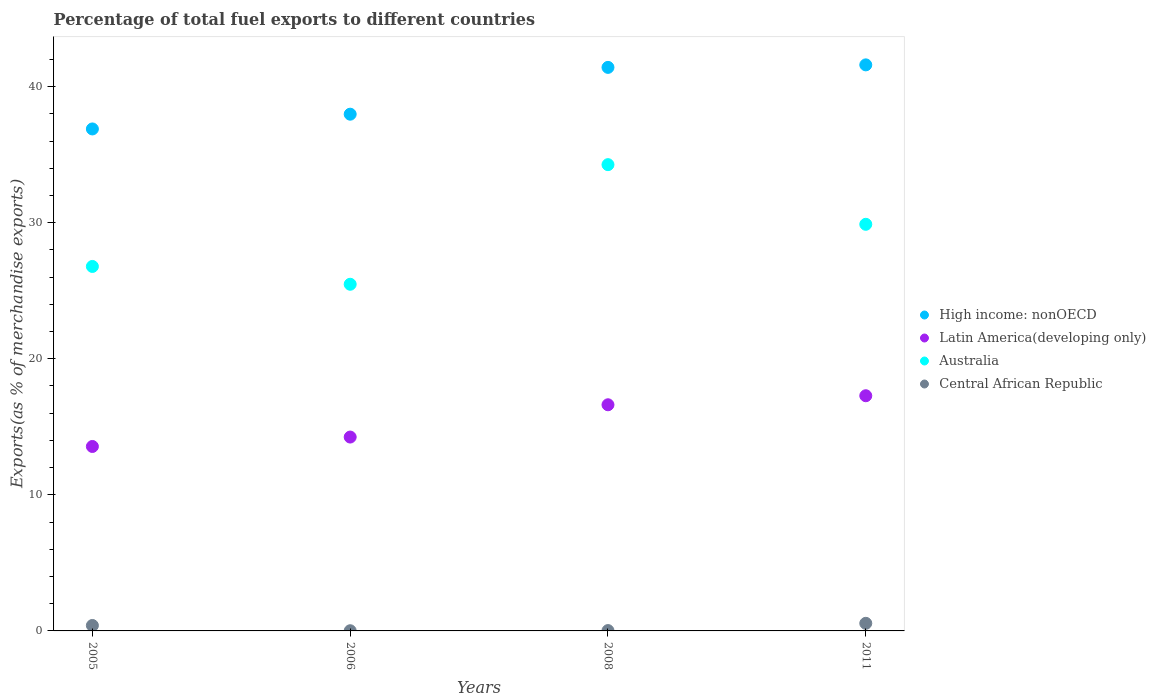How many different coloured dotlines are there?
Keep it short and to the point. 4. What is the percentage of exports to different countries in Central African Republic in 2006?
Your answer should be very brief. 0.01. Across all years, what is the maximum percentage of exports to different countries in High income: nonOECD?
Your answer should be very brief. 41.6. Across all years, what is the minimum percentage of exports to different countries in High income: nonOECD?
Ensure brevity in your answer.  36.89. What is the total percentage of exports to different countries in Latin America(developing only) in the graph?
Keep it short and to the point. 61.71. What is the difference between the percentage of exports to different countries in Central African Republic in 2005 and that in 2008?
Offer a terse response. 0.38. What is the difference between the percentage of exports to different countries in High income: nonOECD in 2006 and the percentage of exports to different countries in Australia in 2011?
Offer a very short reply. 8.09. What is the average percentage of exports to different countries in Central African Republic per year?
Offer a terse response. 0.25. In the year 2008, what is the difference between the percentage of exports to different countries in Latin America(developing only) and percentage of exports to different countries in High income: nonOECD?
Your answer should be compact. -24.8. In how many years, is the percentage of exports to different countries in Latin America(developing only) greater than 8 %?
Your answer should be compact. 4. What is the ratio of the percentage of exports to different countries in Central African Republic in 2006 to that in 2008?
Provide a succinct answer. 0.55. Is the difference between the percentage of exports to different countries in Latin America(developing only) in 2008 and 2011 greater than the difference between the percentage of exports to different countries in High income: nonOECD in 2008 and 2011?
Your answer should be very brief. No. What is the difference between the highest and the second highest percentage of exports to different countries in Central African Republic?
Offer a terse response. 0.16. What is the difference between the highest and the lowest percentage of exports to different countries in Latin America(developing only)?
Provide a succinct answer. 3.73. Is the sum of the percentage of exports to different countries in Australia in 2006 and 2008 greater than the maximum percentage of exports to different countries in Central African Republic across all years?
Provide a succinct answer. Yes. Is it the case that in every year, the sum of the percentage of exports to different countries in High income: nonOECD and percentage of exports to different countries in Central African Republic  is greater than the sum of percentage of exports to different countries in Latin America(developing only) and percentage of exports to different countries in Australia?
Make the answer very short. No. Does the percentage of exports to different countries in High income: nonOECD monotonically increase over the years?
Your response must be concise. Yes. Is the percentage of exports to different countries in Latin America(developing only) strictly greater than the percentage of exports to different countries in Australia over the years?
Your answer should be very brief. No. How many years are there in the graph?
Your answer should be compact. 4. What is the difference between two consecutive major ticks on the Y-axis?
Offer a very short reply. 10. Are the values on the major ticks of Y-axis written in scientific E-notation?
Keep it short and to the point. No. Does the graph contain any zero values?
Provide a succinct answer. No. Does the graph contain grids?
Your response must be concise. No. How many legend labels are there?
Give a very brief answer. 4. How are the legend labels stacked?
Provide a short and direct response. Vertical. What is the title of the graph?
Offer a terse response. Percentage of total fuel exports to different countries. Does "Faeroe Islands" appear as one of the legend labels in the graph?
Give a very brief answer. No. What is the label or title of the Y-axis?
Provide a short and direct response. Exports(as % of merchandise exports). What is the Exports(as % of merchandise exports) of High income: nonOECD in 2005?
Make the answer very short. 36.89. What is the Exports(as % of merchandise exports) of Latin America(developing only) in 2005?
Give a very brief answer. 13.56. What is the Exports(as % of merchandise exports) in Australia in 2005?
Give a very brief answer. 26.79. What is the Exports(as % of merchandise exports) of Central African Republic in 2005?
Provide a succinct answer. 0.4. What is the Exports(as % of merchandise exports) of High income: nonOECD in 2006?
Provide a short and direct response. 37.98. What is the Exports(as % of merchandise exports) in Latin America(developing only) in 2006?
Your answer should be compact. 14.25. What is the Exports(as % of merchandise exports) in Australia in 2006?
Your answer should be compact. 25.48. What is the Exports(as % of merchandise exports) in Central African Republic in 2006?
Offer a very short reply. 0.01. What is the Exports(as % of merchandise exports) in High income: nonOECD in 2008?
Provide a succinct answer. 41.42. What is the Exports(as % of merchandise exports) in Latin America(developing only) in 2008?
Your answer should be compact. 16.62. What is the Exports(as % of merchandise exports) in Australia in 2008?
Your answer should be very brief. 34.27. What is the Exports(as % of merchandise exports) in Central African Republic in 2008?
Your answer should be very brief. 0.02. What is the Exports(as % of merchandise exports) in High income: nonOECD in 2011?
Offer a very short reply. 41.6. What is the Exports(as % of merchandise exports) in Latin America(developing only) in 2011?
Give a very brief answer. 17.28. What is the Exports(as % of merchandise exports) of Australia in 2011?
Provide a short and direct response. 29.88. What is the Exports(as % of merchandise exports) of Central African Republic in 2011?
Offer a terse response. 0.56. Across all years, what is the maximum Exports(as % of merchandise exports) of High income: nonOECD?
Your response must be concise. 41.6. Across all years, what is the maximum Exports(as % of merchandise exports) in Latin America(developing only)?
Offer a terse response. 17.28. Across all years, what is the maximum Exports(as % of merchandise exports) of Australia?
Your answer should be very brief. 34.27. Across all years, what is the maximum Exports(as % of merchandise exports) in Central African Republic?
Provide a short and direct response. 0.56. Across all years, what is the minimum Exports(as % of merchandise exports) of High income: nonOECD?
Give a very brief answer. 36.89. Across all years, what is the minimum Exports(as % of merchandise exports) of Latin America(developing only)?
Provide a short and direct response. 13.56. Across all years, what is the minimum Exports(as % of merchandise exports) of Australia?
Ensure brevity in your answer.  25.48. Across all years, what is the minimum Exports(as % of merchandise exports) of Central African Republic?
Your response must be concise. 0.01. What is the total Exports(as % of merchandise exports) of High income: nonOECD in the graph?
Keep it short and to the point. 157.88. What is the total Exports(as % of merchandise exports) in Latin America(developing only) in the graph?
Keep it short and to the point. 61.71. What is the total Exports(as % of merchandise exports) in Australia in the graph?
Your response must be concise. 116.41. What is the total Exports(as % of merchandise exports) of Central African Republic in the graph?
Ensure brevity in your answer.  1. What is the difference between the Exports(as % of merchandise exports) in High income: nonOECD in 2005 and that in 2006?
Provide a succinct answer. -1.08. What is the difference between the Exports(as % of merchandise exports) of Latin America(developing only) in 2005 and that in 2006?
Keep it short and to the point. -0.69. What is the difference between the Exports(as % of merchandise exports) of Australia in 2005 and that in 2006?
Give a very brief answer. 1.31. What is the difference between the Exports(as % of merchandise exports) of Central African Republic in 2005 and that in 2006?
Offer a very short reply. 0.39. What is the difference between the Exports(as % of merchandise exports) of High income: nonOECD in 2005 and that in 2008?
Offer a terse response. -4.52. What is the difference between the Exports(as % of merchandise exports) in Latin America(developing only) in 2005 and that in 2008?
Provide a short and direct response. -3.07. What is the difference between the Exports(as % of merchandise exports) of Australia in 2005 and that in 2008?
Your answer should be very brief. -7.48. What is the difference between the Exports(as % of merchandise exports) of Central African Republic in 2005 and that in 2008?
Give a very brief answer. 0.38. What is the difference between the Exports(as % of merchandise exports) in High income: nonOECD in 2005 and that in 2011?
Offer a terse response. -4.71. What is the difference between the Exports(as % of merchandise exports) in Latin America(developing only) in 2005 and that in 2011?
Make the answer very short. -3.73. What is the difference between the Exports(as % of merchandise exports) of Australia in 2005 and that in 2011?
Offer a very short reply. -3.1. What is the difference between the Exports(as % of merchandise exports) of Central African Republic in 2005 and that in 2011?
Provide a short and direct response. -0.16. What is the difference between the Exports(as % of merchandise exports) in High income: nonOECD in 2006 and that in 2008?
Offer a terse response. -3.44. What is the difference between the Exports(as % of merchandise exports) in Latin America(developing only) in 2006 and that in 2008?
Provide a succinct answer. -2.37. What is the difference between the Exports(as % of merchandise exports) of Australia in 2006 and that in 2008?
Make the answer very short. -8.79. What is the difference between the Exports(as % of merchandise exports) of Central African Republic in 2006 and that in 2008?
Provide a short and direct response. -0.01. What is the difference between the Exports(as % of merchandise exports) of High income: nonOECD in 2006 and that in 2011?
Ensure brevity in your answer.  -3.62. What is the difference between the Exports(as % of merchandise exports) in Latin America(developing only) in 2006 and that in 2011?
Provide a short and direct response. -3.04. What is the difference between the Exports(as % of merchandise exports) of Australia in 2006 and that in 2011?
Keep it short and to the point. -4.41. What is the difference between the Exports(as % of merchandise exports) in Central African Republic in 2006 and that in 2011?
Keep it short and to the point. -0.54. What is the difference between the Exports(as % of merchandise exports) of High income: nonOECD in 2008 and that in 2011?
Ensure brevity in your answer.  -0.18. What is the difference between the Exports(as % of merchandise exports) of Latin America(developing only) in 2008 and that in 2011?
Ensure brevity in your answer.  -0.66. What is the difference between the Exports(as % of merchandise exports) in Australia in 2008 and that in 2011?
Make the answer very short. 4.38. What is the difference between the Exports(as % of merchandise exports) of Central African Republic in 2008 and that in 2011?
Your response must be concise. -0.53. What is the difference between the Exports(as % of merchandise exports) of High income: nonOECD in 2005 and the Exports(as % of merchandise exports) of Latin America(developing only) in 2006?
Offer a very short reply. 22.64. What is the difference between the Exports(as % of merchandise exports) of High income: nonOECD in 2005 and the Exports(as % of merchandise exports) of Australia in 2006?
Keep it short and to the point. 11.42. What is the difference between the Exports(as % of merchandise exports) in High income: nonOECD in 2005 and the Exports(as % of merchandise exports) in Central African Republic in 2006?
Ensure brevity in your answer.  36.88. What is the difference between the Exports(as % of merchandise exports) in Latin America(developing only) in 2005 and the Exports(as % of merchandise exports) in Australia in 2006?
Provide a short and direct response. -11.92. What is the difference between the Exports(as % of merchandise exports) in Latin America(developing only) in 2005 and the Exports(as % of merchandise exports) in Central African Republic in 2006?
Offer a terse response. 13.54. What is the difference between the Exports(as % of merchandise exports) of Australia in 2005 and the Exports(as % of merchandise exports) of Central African Republic in 2006?
Provide a succinct answer. 26.77. What is the difference between the Exports(as % of merchandise exports) of High income: nonOECD in 2005 and the Exports(as % of merchandise exports) of Latin America(developing only) in 2008?
Offer a very short reply. 20.27. What is the difference between the Exports(as % of merchandise exports) of High income: nonOECD in 2005 and the Exports(as % of merchandise exports) of Australia in 2008?
Make the answer very short. 2.62. What is the difference between the Exports(as % of merchandise exports) in High income: nonOECD in 2005 and the Exports(as % of merchandise exports) in Central African Republic in 2008?
Keep it short and to the point. 36.87. What is the difference between the Exports(as % of merchandise exports) in Latin America(developing only) in 2005 and the Exports(as % of merchandise exports) in Australia in 2008?
Your answer should be very brief. -20.71. What is the difference between the Exports(as % of merchandise exports) of Latin America(developing only) in 2005 and the Exports(as % of merchandise exports) of Central African Republic in 2008?
Your answer should be very brief. 13.53. What is the difference between the Exports(as % of merchandise exports) in Australia in 2005 and the Exports(as % of merchandise exports) in Central African Republic in 2008?
Provide a short and direct response. 26.76. What is the difference between the Exports(as % of merchandise exports) in High income: nonOECD in 2005 and the Exports(as % of merchandise exports) in Latin America(developing only) in 2011?
Offer a very short reply. 19.61. What is the difference between the Exports(as % of merchandise exports) in High income: nonOECD in 2005 and the Exports(as % of merchandise exports) in Australia in 2011?
Give a very brief answer. 7.01. What is the difference between the Exports(as % of merchandise exports) in High income: nonOECD in 2005 and the Exports(as % of merchandise exports) in Central African Republic in 2011?
Provide a succinct answer. 36.33. What is the difference between the Exports(as % of merchandise exports) of Latin America(developing only) in 2005 and the Exports(as % of merchandise exports) of Australia in 2011?
Make the answer very short. -16.33. What is the difference between the Exports(as % of merchandise exports) of Latin America(developing only) in 2005 and the Exports(as % of merchandise exports) of Central African Republic in 2011?
Your answer should be compact. 13. What is the difference between the Exports(as % of merchandise exports) of Australia in 2005 and the Exports(as % of merchandise exports) of Central African Republic in 2011?
Offer a terse response. 26.23. What is the difference between the Exports(as % of merchandise exports) of High income: nonOECD in 2006 and the Exports(as % of merchandise exports) of Latin America(developing only) in 2008?
Provide a short and direct response. 21.36. What is the difference between the Exports(as % of merchandise exports) in High income: nonOECD in 2006 and the Exports(as % of merchandise exports) in Australia in 2008?
Your answer should be compact. 3.71. What is the difference between the Exports(as % of merchandise exports) in High income: nonOECD in 2006 and the Exports(as % of merchandise exports) in Central African Republic in 2008?
Provide a short and direct response. 37.95. What is the difference between the Exports(as % of merchandise exports) in Latin America(developing only) in 2006 and the Exports(as % of merchandise exports) in Australia in 2008?
Keep it short and to the point. -20.02. What is the difference between the Exports(as % of merchandise exports) of Latin America(developing only) in 2006 and the Exports(as % of merchandise exports) of Central African Republic in 2008?
Your response must be concise. 14.22. What is the difference between the Exports(as % of merchandise exports) in Australia in 2006 and the Exports(as % of merchandise exports) in Central African Republic in 2008?
Give a very brief answer. 25.45. What is the difference between the Exports(as % of merchandise exports) of High income: nonOECD in 2006 and the Exports(as % of merchandise exports) of Latin America(developing only) in 2011?
Give a very brief answer. 20.69. What is the difference between the Exports(as % of merchandise exports) in High income: nonOECD in 2006 and the Exports(as % of merchandise exports) in Australia in 2011?
Provide a succinct answer. 8.09. What is the difference between the Exports(as % of merchandise exports) of High income: nonOECD in 2006 and the Exports(as % of merchandise exports) of Central African Republic in 2011?
Your response must be concise. 37.42. What is the difference between the Exports(as % of merchandise exports) in Latin America(developing only) in 2006 and the Exports(as % of merchandise exports) in Australia in 2011?
Provide a short and direct response. -15.64. What is the difference between the Exports(as % of merchandise exports) in Latin America(developing only) in 2006 and the Exports(as % of merchandise exports) in Central African Republic in 2011?
Your response must be concise. 13.69. What is the difference between the Exports(as % of merchandise exports) in Australia in 2006 and the Exports(as % of merchandise exports) in Central African Republic in 2011?
Make the answer very short. 24.92. What is the difference between the Exports(as % of merchandise exports) in High income: nonOECD in 2008 and the Exports(as % of merchandise exports) in Latin America(developing only) in 2011?
Provide a short and direct response. 24.13. What is the difference between the Exports(as % of merchandise exports) in High income: nonOECD in 2008 and the Exports(as % of merchandise exports) in Australia in 2011?
Give a very brief answer. 11.53. What is the difference between the Exports(as % of merchandise exports) of High income: nonOECD in 2008 and the Exports(as % of merchandise exports) of Central African Republic in 2011?
Your answer should be very brief. 40.86. What is the difference between the Exports(as % of merchandise exports) of Latin America(developing only) in 2008 and the Exports(as % of merchandise exports) of Australia in 2011?
Make the answer very short. -13.26. What is the difference between the Exports(as % of merchandise exports) of Latin America(developing only) in 2008 and the Exports(as % of merchandise exports) of Central African Republic in 2011?
Make the answer very short. 16.06. What is the difference between the Exports(as % of merchandise exports) of Australia in 2008 and the Exports(as % of merchandise exports) of Central African Republic in 2011?
Make the answer very short. 33.71. What is the average Exports(as % of merchandise exports) in High income: nonOECD per year?
Your response must be concise. 39.47. What is the average Exports(as % of merchandise exports) in Latin America(developing only) per year?
Give a very brief answer. 15.43. What is the average Exports(as % of merchandise exports) in Australia per year?
Give a very brief answer. 29.1. What is the average Exports(as % of merchandise exports) in Central African Republic per year?
Keep it short and to the point. 0.25. In the year 2005, what is the difference between the Exports(as % of merchandise exports) of High income: nonOECD and Exports(as % of merchandise exports) of Latin America(developing only)?
Make the answer very short. 23.34. In the year 2005, what is the difference between the Exports(as % of merchandise exports) of High income: nonOECD and Exports(as % of merchandise exports) of Australia?
Offer a very short reply. 10.11. In the year 2005, what is the difference between the Exports(as % of merchandise exports) in High income: nonOECD and Exports(as % of merchandise exports) in Central African Republic?
Provide a short and direct response. 36.49. In the year 2005, what is the difference between the Exports(as % of merchandise exports) of Latin America(developing only) and Exports(as % of merchandise exports) of Australia?
Offer a very short reply. -13.23. In the year 2005, what is the difference between the Exports(as % of merchandise exports) of Latin America(developing only) and Exports(as % of merchandise exports) of Central African Republic?
Make the answer very short. 13.16. In the year 2005, what is the difference between the Exports(as % of merchandise exports) in Australia and Exports(as % of merchandise exports) in Central African Republic?
Your answer should be compact. 26.39. In the year 2006, what is the difference between the Exports(as % of merchandise exports) in High income: nonOECD and Exports(as % of merchandise exports) in Latin America(developing only)?
Your answer should be compact. 23.73. In the year 2006, what is the difference between the Exports(as % of merchandise exports) in High income: nonOECD and Exports(as % of merchandise exports) in Australia?
Keep it short and to the point. 12.5. In the year 2006, what is the difference between the Exports(as % of merchandise exports) in High income: nonOECD and Exports(as % of merchandise exports) in Central African Republic?
Ensure brevity in your answer.  37.96. In the year 2006, what is the difference between the Exports(as % of merchandise exports) of Latin America(developing only) and Exports(as % of merchandise exports) of Australia?
Keep it short and to the point. -11.23. In the year 2006, what is the difference between the Exports(as % of merchandise exports) of Latin America(developing only) and Exports(as % of merchandise exports) of Central African Republic?
Ensure brevity in your answer.  14.23. In the year 2006, what is the difference between the Exports(as % of merchandise exports) of Australia and Exports(as % of merchandise exports) of Central African Republic?
Keep it short and to the point. 25.46. In the year 2008, what is the difference between the Exports(as % of merchandise exports) of High income: nonOECD and Exports(as % of merchandise exports) of Latin America(developing only)?
Keep it short and to the point. 24.8. In the year 2008, what is the difference between the Exports(as % of merchandise exports) of High income: nonOECD and Exports(as % of merchandise exports) of Australia?
Your response must be concise. 7.15. In the year 2008, what is the difference between the Exports(as % of merchandise exports) of High income: nonOECD and Exports(as % of merchandise exports) of Central African Republic?
Ensure brevity in your answer.  41.39. In the year 2008, what is the difference between the Exports(as % of merchandise exports) of Latin America(developing only) and Exports(as % of merchandise exports) of Australia?
Your answer should be compact. -17.65. In the year 2008, what is the difference between the Exports(as % of merchandise exports) in Latin America(developing only) and Exports(as % of merchandise exports) in Central African Republic?
Your answer should be compact. 16.6. In the year 2008, what is the difference between the Exports(as % of merchandise exports) in Australia and Exports(as % of merchandise exports) in Central African Republic?
Ensure brevity in your answer.  34.24. In the year 2011, what is the difference between the Exports(as % of merchandise exports) in High income: nonOECD and Exports(as % of merchandise exports) in Latin America(developing only)?
Give a very brief answer. 24.32. In the year 2011, what is the difference between the Exports(as % of merchandise exports) in High income: nonOECD and Exports(as % of merchandise exports) in Australia?
Your answer should be very brief. 11.72. In the year 2011, what is the difference between the Exports(as % of merchandise exports) of High income: nonOECD and Exports(as % of merchandise exports) of Central African Republic?
Provide a short and direct response. 41.04. In the year 2011, what is the difference between the Exports(as % of merchandise exports) of Latin America(developing only) and Exports(as % of merchandise exports) of Australia?
Your response must be concise. -12.6. In the year 2011, what is the difference between the Exports(as % of merchandise exports) of Latin America(developing only) and Exports(as % of merchandise exports) of Central African Republic?
Offer a terse response. 16.73. In the year 2011, what is the difference between the Exports(as % of merchandise exports) in Australia and Exports(as % of merchandise exports) in Central African Republic?
Provide a short and direct response. 29.32. What is the ratio of the Exports(as % of merchandise exports) in High income: nonOECD in 2005 to that in 2006?
Provide a succinct answer. 0.97. What is the ratio of the Exports(as % of merchandise exports) of Latin America(developing only) in 2005 to that in 2006?
Your answer should be compact. 0.95. What is the ratio of the Exports(as % of merchandise exports) of Australia in 2005 to that in 2006?
Ensure brevity in your answer.  1.05. What is the ratio of the Exports(as % of merchandise exports) in Central African Republic in 2005 to that in 2006?
Offer a terse response. 29.62. What is the ratio of the Exports(as % of merchandise exports) of High income: nonOECD in 2005 to that in 2008?
Ensure brevity in your answer.  0.89. What is the ratio of the Exports(as % of merchandise exports) in Latin America(developing only) in 2005 to that in 2008?
Your answer should be compact. 0.82. What is the ratio of the Exports(as % of merchandise exports) of Australia in 2005 to that in 2008?
Ensure brevity in your answer.  0.78. What is the ratio of the Exports(as % of merchandise exports) of Central African Republic in 2005 to that in 2008?
Provide a succinct answer. 16.35. What is the ratio of the Exports(as % of merchandise exports) of High income: nonOECD in 2005 to that in 2011?
Give a very brief answer. 0.89. What is the ratio of the Exports(as % of merchandise exports) of Latin America(developing only) in 2005 to that in 2011?
Keep it short and to the point. 0.78. What is the ratio of the Exports(as % of merchandise exports) of Australia in 2005 to that in 2011?
Offer a terse response. 0.9. What is the ratio of the Exports(as % of merchandise exports) in Central African Republic in 2005 to that in 2011?
Ensure brevity in your answer.  0.72. What is the ratio of the Exports(as % of merchandise exports) of High income: nonOECD in 2006 to that in 2008?
Your response must be concise. 0.92. What is the ratio of the Exports(as % of merchandise exports) of Latin America(developing only) in 2006 to that in 2008?
Make the answer very short. 0.86. What is the ratio of the Exports(as % of merchandise exports) in Australia in 2006 to that in 2008?
Offer a terse response. 0.74. What is the ratio of the Exports(as % of merchandise exports) of Central African Republic in 2006 to that in 2008?
Your answer should be compact. 0.55. What is the ratio of the Exports(as % of merchandise exports) in High income: nonOECD in 2006 to that in 2011?
Keep it short and to the point. 0.91. What is the ratio of the Exports(as % of merchandise exports) of Latin America(developing only) in 2006 to that in 2011?
Give a very brief answer. 0.82. What is the ratio of the Exports(as % of merchandise exports) in Australia in 2006 to that in 2011?
Your response must be concise. 0.85. What is the ratio of the Exports(as % of merchandise exports) of Central African Republic in 2006 to that in 2011?
Your answer should be compact. 0.02. What is the ratio of the Exports(as % of merchandise exports) of High income: nonOECD in 2008 to that in 2011?
Make the answer very short. 1. What is the ratio of the Exports(as % of merchandise exports) of Latin America(developing only) in 2008 to that in 2011?
Your response must be concise. 0.96. What is the ratio of the Exports(as % of merchandise exports) in Australia in 2008 to that in 2011?
Provide a short and direct response. 1.15. What is the ratio of the Exports(as % of merchandise exports) of Central African Republic in 2008 to that in 2011?
Your answer should be compact. 0.04. What is the difference between the highest and the second highest Exports(as % of merchandise exports) of High income: nonOECD?
Ensure brevity in your answer.  0.18. What is the difference between the highest and the second highest Exports(as % of merchandise exports) in Latin America(developing only)?
Give a very brief answer. 0.66. What is the difference between the highest and the second highest Exports(as % of merchandise exports) of Australia?
Keep it short and to the point. 4.38. What is the difference between the highest and the second highest Exports(as % of merchandise exports) of Central African Republic?
Keep it short and to the point. 0.16. What is the difference between the highest and the lowest Exports(as % of merchandise exports) in High income: nonOECD?
Your answer should be very brief. 4.71. What is the difference between the highest and the lowest Exports(as % of merchandise exports) of Latin America(developing only)?
Keep it short and to the point. 3.73. What is the difference between the highest and the lowest Exports(as % of merchandise exports) of Australia?
Offer a terse response. 8.79. What is the difference between the highest and the lowest Exports(as % of merchandise exports) of Central African Republic?
Your answer should be compact. 0.54. 